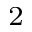Convert formula to latex. <formula><loc_0><loc_0><loc_500><loc_500>^ { 2 }</formula> 